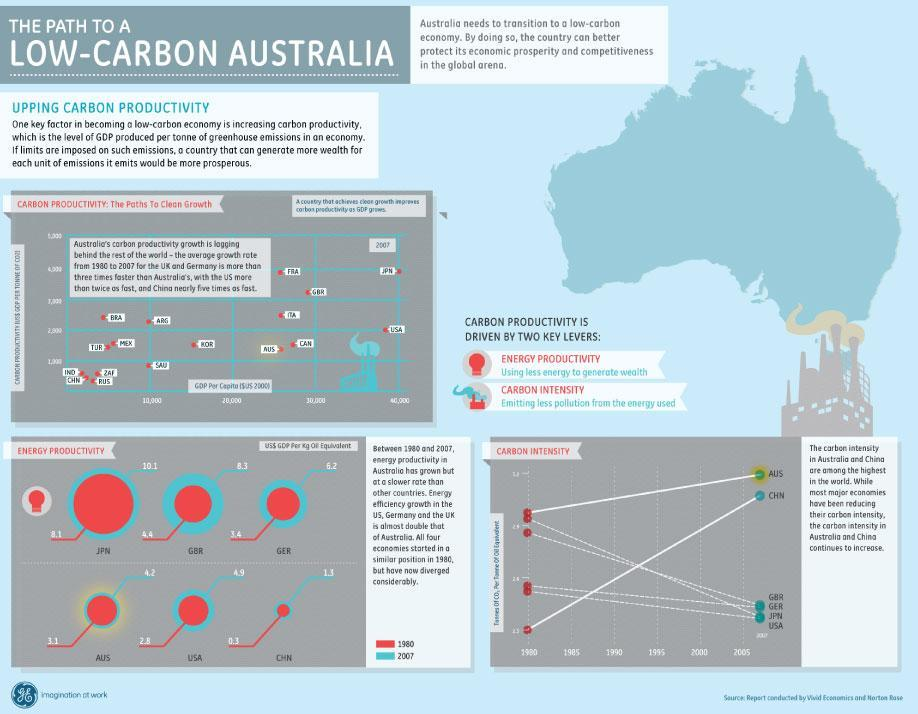What was the energy productivity of USA in 1980?
Answer the question with a short phrase. 2.8 Which country has the lowest energy productivity in 1980 USA, GBR, or JPN ? USA Which country has second  highest value in energy productivity in the year 1980? 4.4 Which country among GBR, GER, and AUS has the highest energy productivity in 2007? GBR, Great Britain Which country shows the lowest GDP per capita in 2007 in terms of carbon productivity ? IND, India What is the third lowest value in energy productivity in the year 2007 ? 4.9 What is energy productivity achieved by Japan in the year 2007? 10.1 What was the energy productivity of GBR in 2007 ? 8.3 Which country shows the least energy productivity in the year 1980? CHN, China Which country shows the highest GDP per Capita in 2007 in terms of carbon productivity? JPN, Japan 